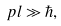Convert formula to latex. <formula><loc_0><loc_0><loc_500><loc_500>p l \gg \hbar { , }</formula> 